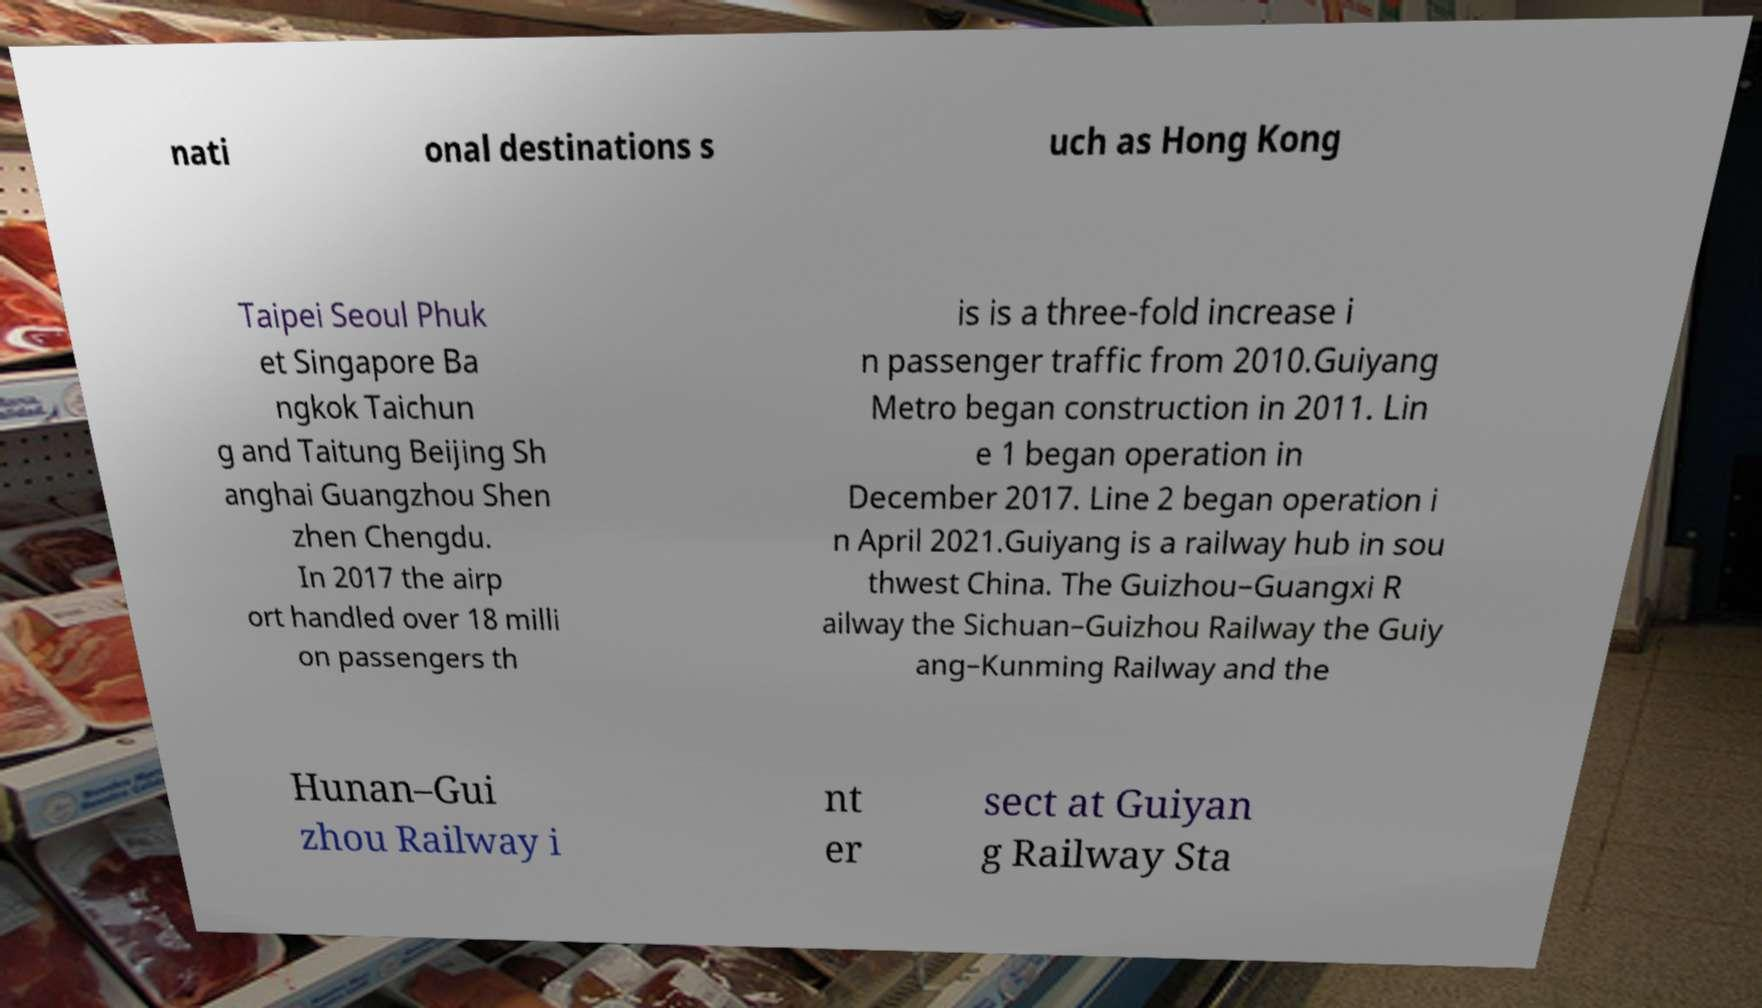I need the written content from this picture converted into text. Can you do that? nati onal destinations s uch as Hong Kong Taipei Seoul Phuk et Singapore Ba ngkok Taichun g and Taitung Beijing Sh anghai Guangzhou Shen zhen Chengdu. In 2017 the airp ort handled over 18 milli on passengers th is is a three-fold increase i n passenger traffic from 2010.Guiyang Metro began construction in 2011. Lin e 1 began operation in December 2017. Line 2 began operation i n April 2021.Guiyang is a railway hub in sou thwest China. The Guizhou–Guangxi R ailway the Sichuan–Guizhou Railway the Guiy ang–Kunming Railway and the Hunan–Gui zhou Railway i nt er sect at Guiyan g Railway Sta 